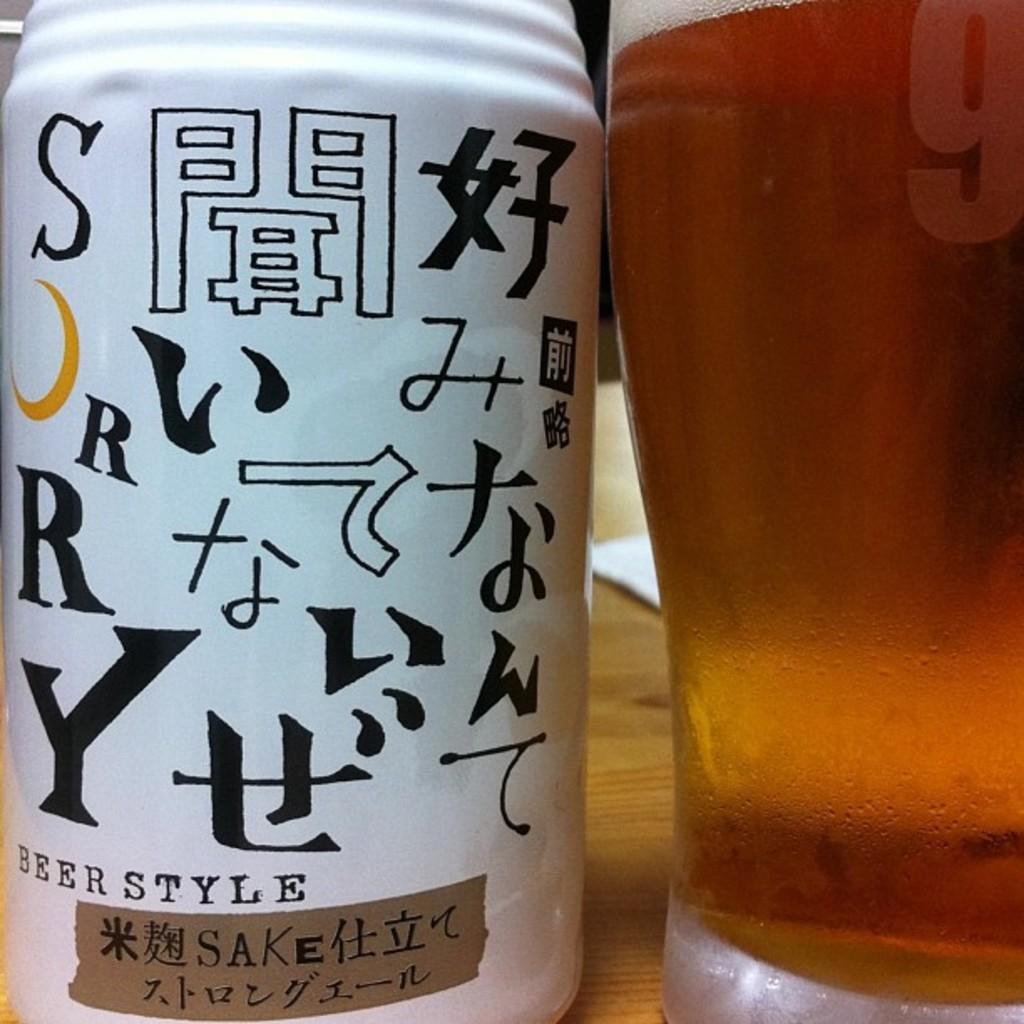<image>
Create a compact narrative representing the image presented. A can of Beer Style Sake sits on a table. 